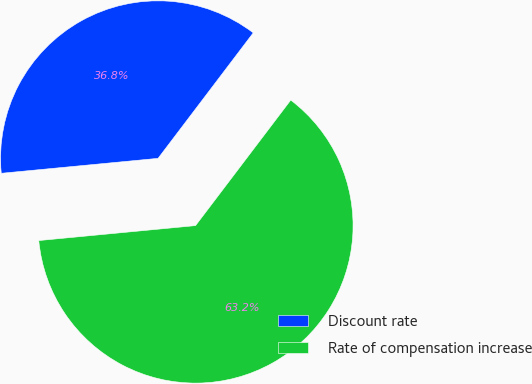Convert chart to OTSL. <chart><loc_0><loc_0><loc_500><loc_500><pie_chart><fcel>Discount rate<fcel>Rate of compensation increase<nl><fcel>36.84%<fcel>63.16%<nl></chart> 